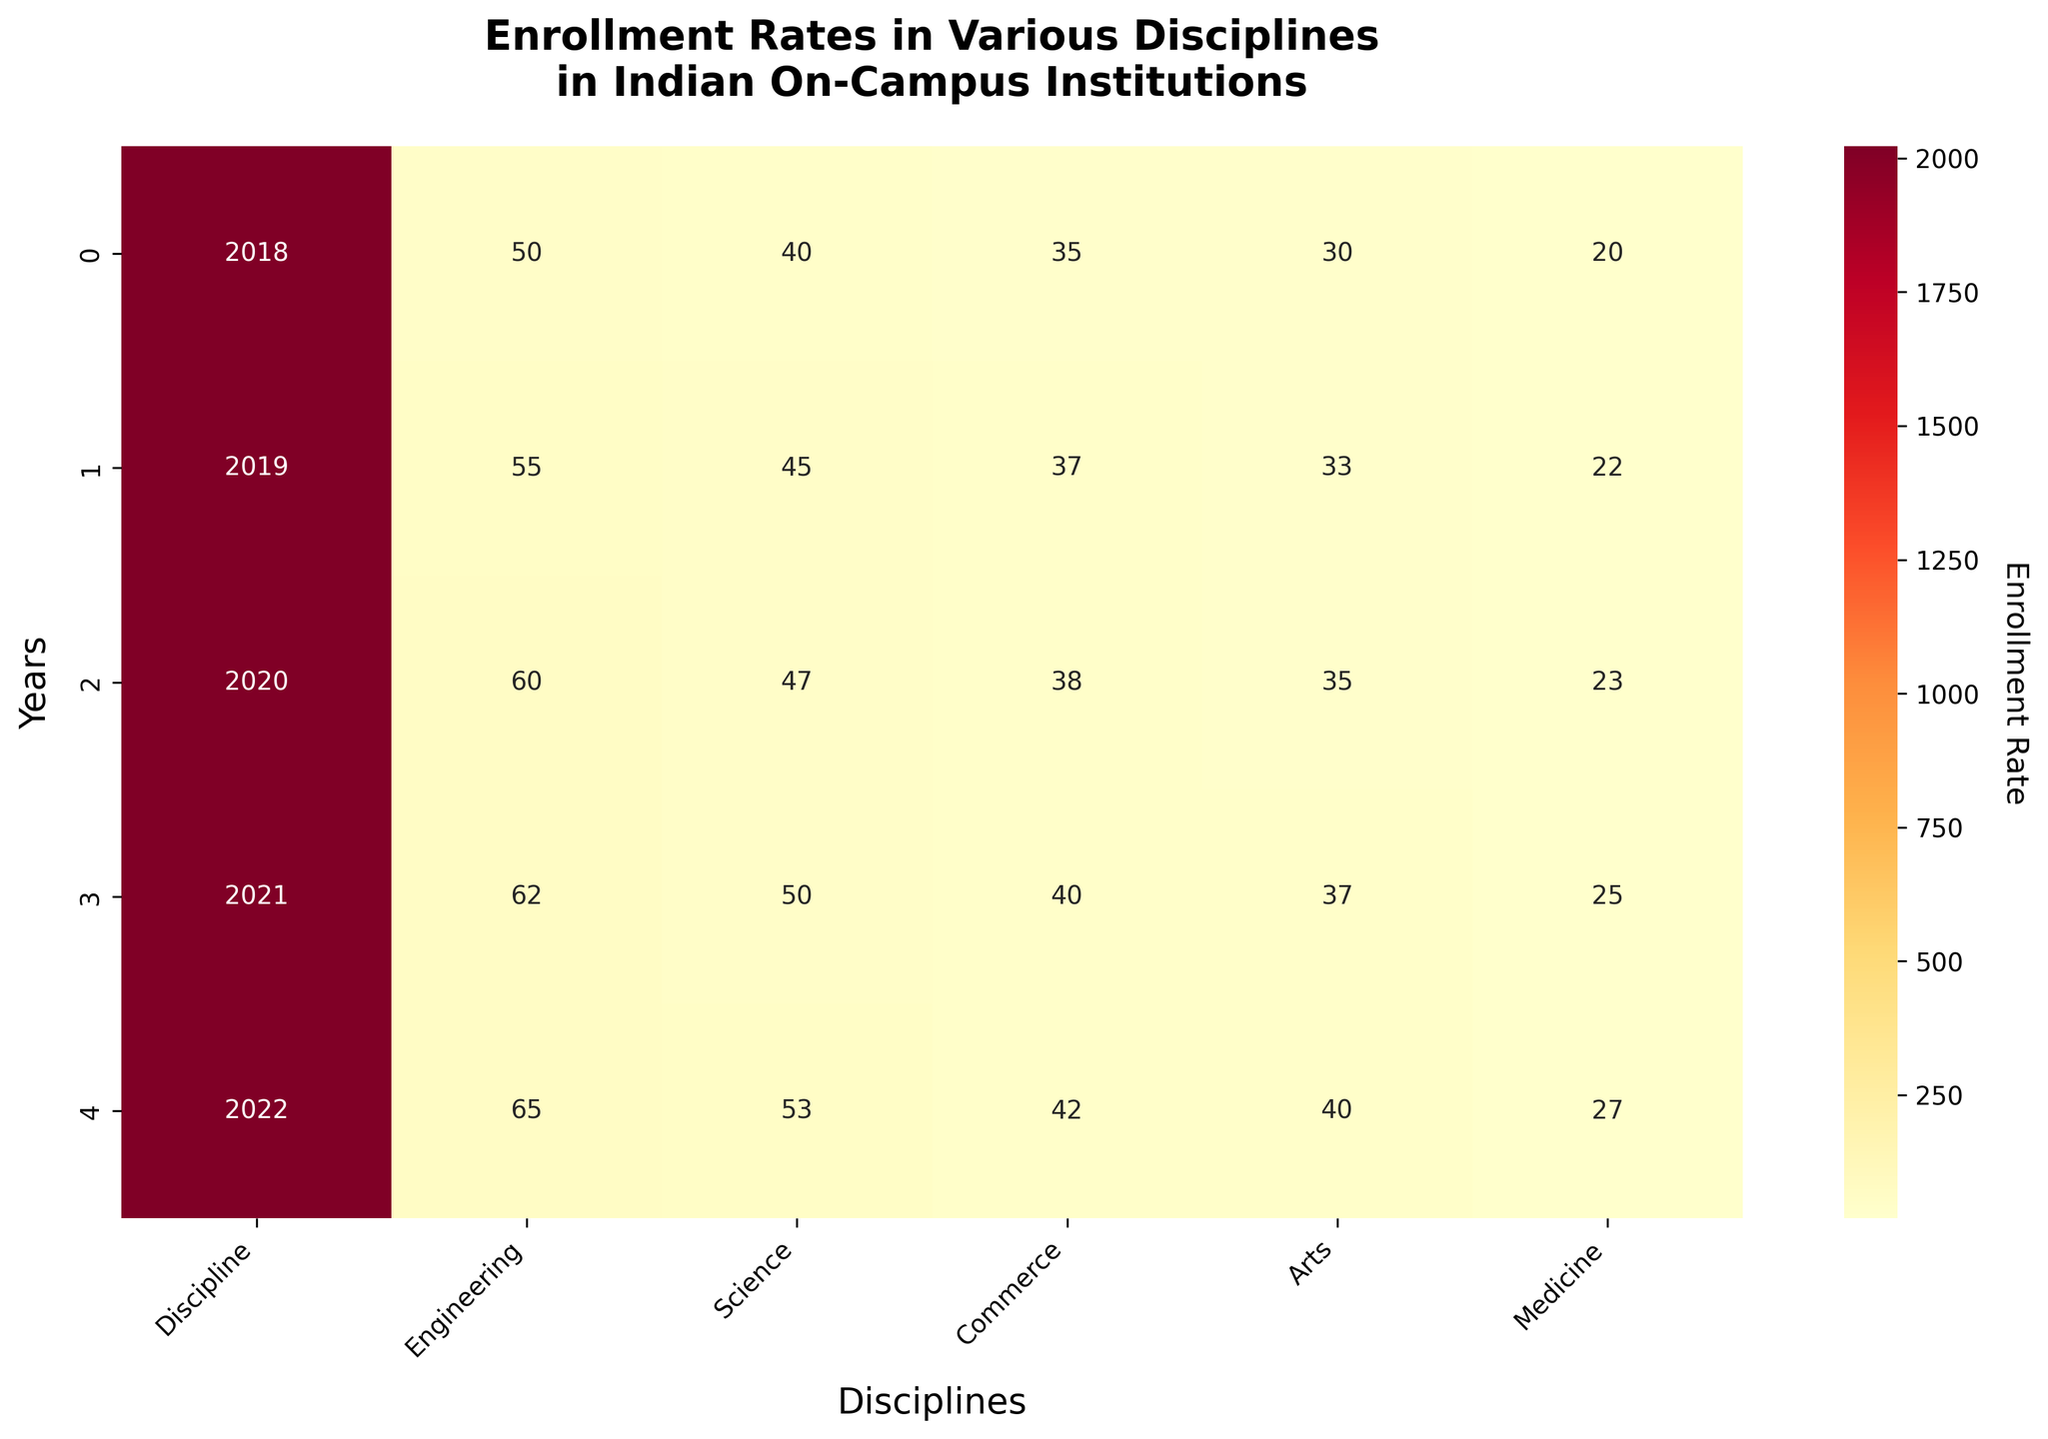Which discipline had the highest enrollment rate in 2022? Look at the row for 2022 and find the highest value. The highest value in the row is 65 under the Engineering discipline.
Answer: Engineering What is the total enrollment rate for Science across all years? Sum up the enrollment rates for Science from 2018 to 2022: 40 + 45 + 47 + 50 + 53 = 235.
Answer: 235 How did the enrollment rate for Commerce change from 2018 to 2022? Subtract the enrollment rate of Commerce in 2018 from the enrollment rate in 2022: 42 - 35 = 7. The enrollment rate for Commerce increased by 7 points.
Answer: Increased by 7 points Between Medicine and Arts, which discipline had a higher enrollment rate in 2020? Compare the values for Medicine (23) and Arts (35) in the year 2020. Arts had a higher enrollment rate.
Answer: Arts What is the average enrollment rate for Engineering over the five years? Sum the enrollment rates for Engineering from 2018 to 2022 and divide by 5: (50 + 55 + 60 + 62 + 65) / 5 = 58.4.
Answer: 58.4 Which discipline exhibited the most consistent increase in enrollment rates over the years? Observe the increments in each discipline. Engineering shows consistent increases: 50, 55, 60, 62, 65.
Answer: Engineering What is the difference between the highest and lowest enrollment rates for Arts from 2018 to 2022? Identify the highest (40 in 2022) and lowest (30 in 2018) enrollment rates for Arts and subtract: 40 - 30 = 10.
Answer: 10 How many disciplines had an enrollment rate of 40 or more by the year 2021? Look at the row for 2021 and count the disciplines with enrollment rates ≥ 40: Engineering, Science, and Commerce. There are 3.
Answer: 3 Which year saw the largest overall increase in enrollment rates for Medicine? Compare the year-to-year differences in Medicine: 2018 to 2019 (2), 2019 to 2020 (1), 2020 to 2021 (2), 2021 to 2022 (2). Each increment is relatively small, but there are two larger increments of 2 in 2018-2019 and 2021-2022.
Answer: 2021-2022 From 2018 to 2022, how many times did the enrollment rate for Commerce exceed that of Medicine in any given year? Compare the annual enrollment rates for Commerce and Medicine: (Commerce: 35 > Medicine: 20 in 2018), (Commerce: 37 > Medicine: 22 in 2019), (Commerce: 38 > Medicine: 23 in 2020), (Commerce: 40 > Medicine: 25 in 2021), and (Commerce: 42 > Medicine: 27 in 2022). The rate for Commerce exceeded Medicine 5 times.
Answer: 5 